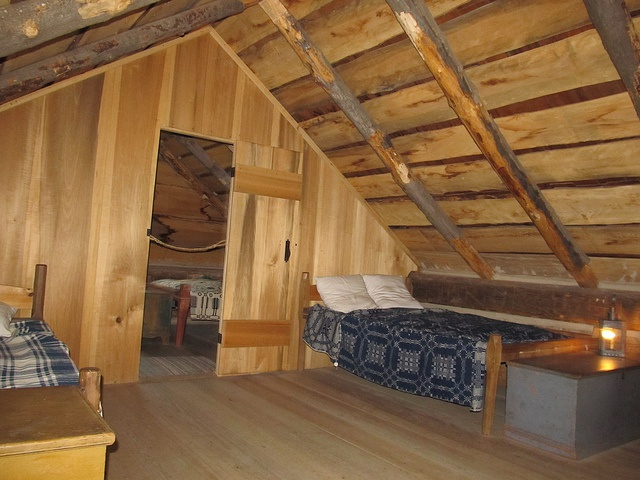Describe the objects in this image and their specific colors. I can see bed in olive, black, gray, maroon, and brown tones, bed in olive, gray, tan, and darkgray tones, and bed in olive and gray tones in this image. 